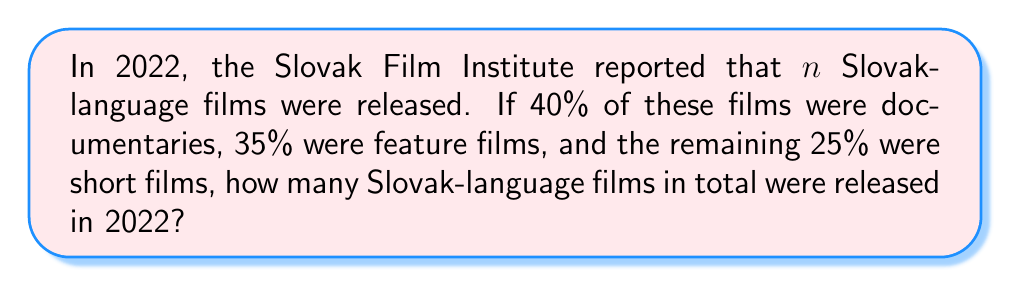Help me with this question. Let's approach this step-by-step:

1) We know that the total number of films is divided into three categories:
   - Documentaries: 40%
   - Feature films: 35%
   - Short films: 25%

2) These percentages should add up to 100%:
   $40\% + 35\% + 25\% = 100\%$

3) Let $n$ be the total number of Slovak-language films released in 2022.

4) We can set up an equation based on these percentages:
   $0.40n + 0.35n + 0.25n = n$

5) Simplifying the left side of the equation:
   $(0.40 + 0.35 + 0.25)n = n$
   $1n = n$

6) This equation is true for any value of $n$, which means we don't have enough information to determine the exact number of films.

7) However, since we're dealing with whole films, $n$ must be a positive integer that's divisible by 20 (to allow for exact 5% increments in the percentages).

8) The smallest possible value for $n$ would be 20, as:
   - 40% of 20 is 8 (documentaries)
   - 35% of 20 is 7 (feature films)
   - 25% of 20 is 5 (short films)

9) Any multiple of 20 would also work: 40, 60, 80, etc.
Answer: $n = 20k$, where $k$ is a positive integer 